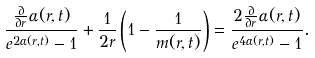Convert formula to latex. <formula><loc_0><loc_0><loc_500><loc_500>\frac { \frac { \partial } { \partial r } \alpha ( r , t ) } { e ^ { 2 \alpha ( r , t ) } - 1 } + \frac { 1 } { 2 r } \left ( 1 - \frac { 1 } { m ( r , t ) } \right ) = \frac { 2 \frac { \partial } { \partial r } \alpha ( r , t ) } { e ^ { 4 \alpha ( r , t ) } - 1 } .</formula> 